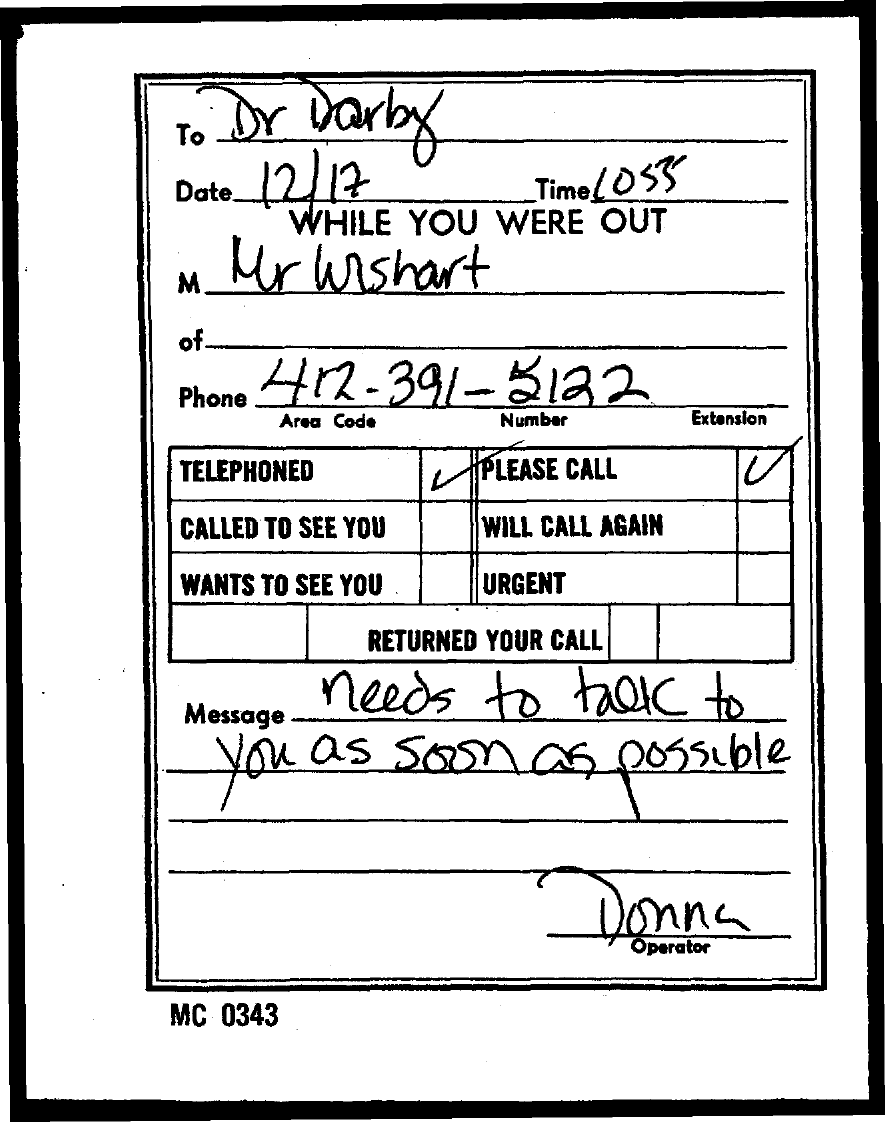Give some essential details in this illustration. The operator is Donna. The document mentions a date of December 17th. The area code is 412… 